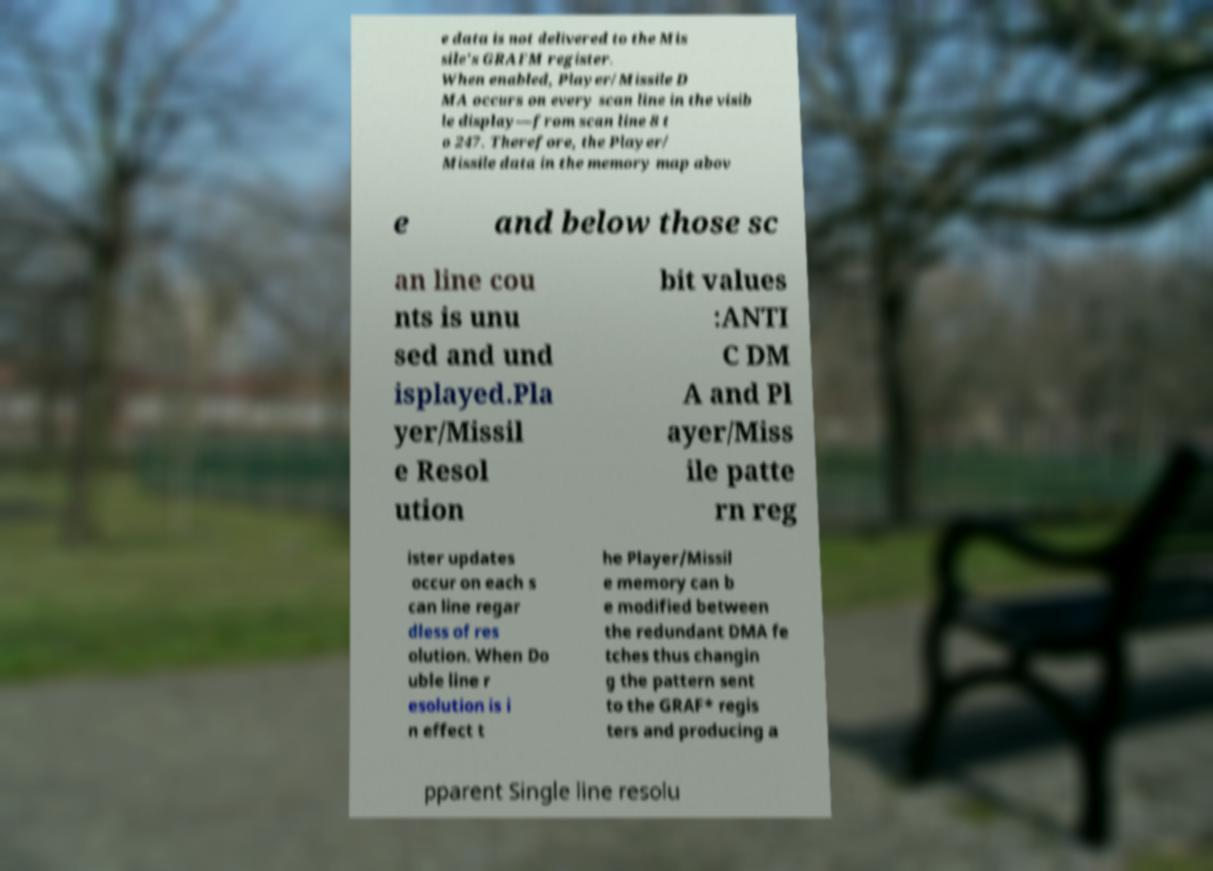Could you extract and type out the text from this image? e data is not delivered to the Mis sile's GRAFM register. When enabled, Player/Missile D MA occurs on every scan line in the visib le display—from scan line 8 t o 247. Therefore, the Player/ Missile data in the memory map abov e and below those sc an line cou nts is unu sed and und isplayed.Pla yer/Missil e Resol ution bit values :ANTI C DM A and Pl ayer/Miss ile patte rn reg ister updates occur on each s can line regar dless of res olution. When Do uble line r esolution is i n effect t he Player/Missil e memory can b e modified between the redundant DMA fe tches thus changin g the pattern sent to the GRAF* regis ters and producing a pparent Single line resolu 